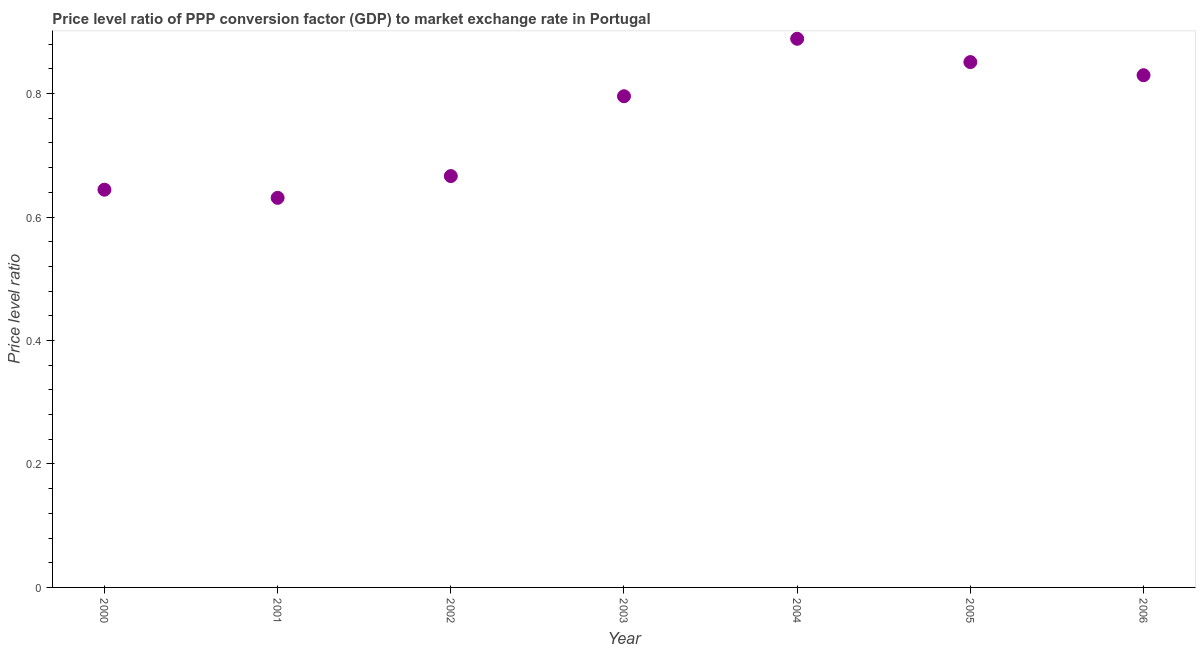What is the price level ratio in 2003?
Ensure brevity in your answer.  0.8. Across all years, what is the maximum price level ratio?
Your response must be concise. 0.89. Across all years, what is the minimum price level ratio?
Provide a succinct answer. 0.63. What is the sum of the price level ratio?
Offer a very short reply. 5.31. What is the difference between the price level ratio in 2000 and 2005?
Provide a succinct answer. -0.21. What is the average price level ratio per year?
Ensure brevity in your answer.  0.76. What is the median price level ratio?
Your answer should be compact. 0.8. In how many years, is the price level ratio greater than 0.44 ?
Offer a terse response. 7. What is the ratio of the price level ratio in 2001 to that in 2006?
Offer a terse response. 0.76. Is the difference between the price level ratio in 2000 and 2006 greater than the difference between any two years?
Give a very brief answer. No. What is the difference between the highest and the second highest price level ratio?
Ensure brevity in your answer.  0.04. What is the difference between the highest and the lowest price level ratio?
Make the answer very short. 0.26. In how many years, is the price level ratio greater than the average price level ratio taken over all years?
Your answer should be compact. 4. Does the price level ratio monotonically increase over the years?
Your response must be concise. No. How many dotlines are there?
Offer a terse response. 1. Are the values on the major ticks of Y-axis written in scientific E-notation?
Your answer should be compact. No. Does the graph contain any zero values?
Provide a short and direct response. No. What is the title of the graph?
Provide a short and direct response. Price level ratio of PPP conversion factor (GDP) to market exchange rate in Portugal. What is the label or title of the Y-axis?
Make the answer very short. Price level ratio. What is the Price level ratio in 2000?
Make the answer very short. 0.64. What is the Price level ratio in 2001?
Make the answer very short. 0.63. What is the Price level ratio in 2002?
Your response must be concise. 0.67. What is the Price level ratio in 2003?
Provide a short and direct response. 0.8. What is the Price level ratio in 2004?
Offer a very short reply. 0.89. What is the Price level ratio in 2005?
Provide a succinct answer. 0.85. What is the Price level ratio in 2006?
Provide a short and direct response. 0.83. What is the difference between the Price level ratio in 2000 and 2001?
Your response must be concise. 0.01. What is the difference between the Price level ratio in 2000 and 2002?
Provide a succinct answer. -0.02. What is the difference between the Price level ratio in 2000 and 2003?
Make the answer very short. -0.15. What is the difference between the Price level ratio in 2000 and 2004?
Ensure brevity in your answer.  -0.24. What is the difference between the Price level ratio in 2000 and 2005?
Provide a succinct answer. -0.21. What is the difference between the Price level ratio in 2000 and 2006?
Offer a very short reply. -0.19. What is the difference between the Price level ratio in 2001 and 2002?
Your answer should be very brief. -0.04. What is the difference between the Price level ratio in 2001 and 2003?
Make the answer very short. -0.16. What is the difference between the Price level ratio in 2001 and 2004?
Offer a terse response. -0.26. What is the difference between the Price level ratio in 2001 and 2005?
Provide a short and direct response. -0.22. What is the difference between the Price level ratio in 2001 and 2006?
Your answer should be compact. -0.2. What is the difference between the Price level ratio in 2002 and 2003?
Offer a very short reply. -0.13. What is the difference between the Price level ratio in 2002 and 2004?
Give a very brief answer. -0.22. What is the difference between the Price level ratio in 2002 and 2005?
Provide a succinct answer. -0.18. What is the difference between the Price level ratio in 2002 and 2006?
Offer a terse response. -0.16. What is the difference between the Price level ratio in 2003 and 2004?
Ensure brevity in your answer.  -0.09. What is the difference between the Price level ratio in 2003 and 2005?
Offer a very short reply. -0.06. What is the difference between the Price level ratio in 2003 and 2006?
Offer a very short reply. -0.03. What is the difference between the Price level ratio in 2004 and 2005?
Provide a short and direct response. 0.04. What is the difference between the Price level ratio in 2004 and 2006?
Offer a terse response. 0.06. What is the difference between the Price level ratio in 2005 and 2006?
Make the answer very short. 0.02. What is the ratio of the Price level ratio in 2000 to that in 2001?
Make the answer very short. 1.02. What is the ratio of the Price level ratio in 2000 to that in 2003?
Your answer should be very brief. 0.81. What is the ratio of the Price level ratio in 2000 to that in 2004?
Make the answer very short. 0.72. What is the ratio of the Price level ratio in 2000 to that in 2005?
Offer a very short reply. 0.76. What is the ratio of the Price level ratio in 2000 to that in 2006?
Ensure brevity in your answer.  0.78. What is the ratio of the Price level ratio in 2001 to that in 2002?
Offer a very short reply. 0.95. What is the ratio of the Price level ratio in 2001 to that in 2003?
Your response must be concise. 0.79. What is the ratio of the Price level ratio in 2001 to that in 2004?
Provide a succinct answer. 0.71. What is the ratio of the Price level ratio in 2001 to that in 2005?
Ensure brevity in your answer.  0.74. What is the ratio of the Price level ratio in 2001 to that in 2006?
Provide a short and direct response. 0.76. What is the ratio of the Price level ratio in 2002 to that in 2003?
Offer a very short reply. 0.84. What is the ratio of the Price level ratio in 2002 to that in 2004?
Ensure brevity in your answer.  0.75. What is the ratio of the Price level ratio in 2002 to that in 2005?
Your answer should be compact. 0.78. What is the ratio of the Price level ratio in 2002 to that in 2006?
Make the answer very short. 0.8. What is the ratio of the Price level ratio in 2003 to that in 2004?
Make the answer very short. 0.9. What is the ratio of the Price level ratio in 2003 to that in 2005?
Your answer should be very brief. 0.94. What is the ratio of the Price level ratio in 2003 to that in 2006?
Your answer should be compact. 0.96. What is the ratio of the Price level ratio in 2004 to that in 2005?
Your answer should be compact. 1.04. What is the ratio of the Price level ratio in 2004 to that in 2006?
Provide a short and direct response. 1.07. 